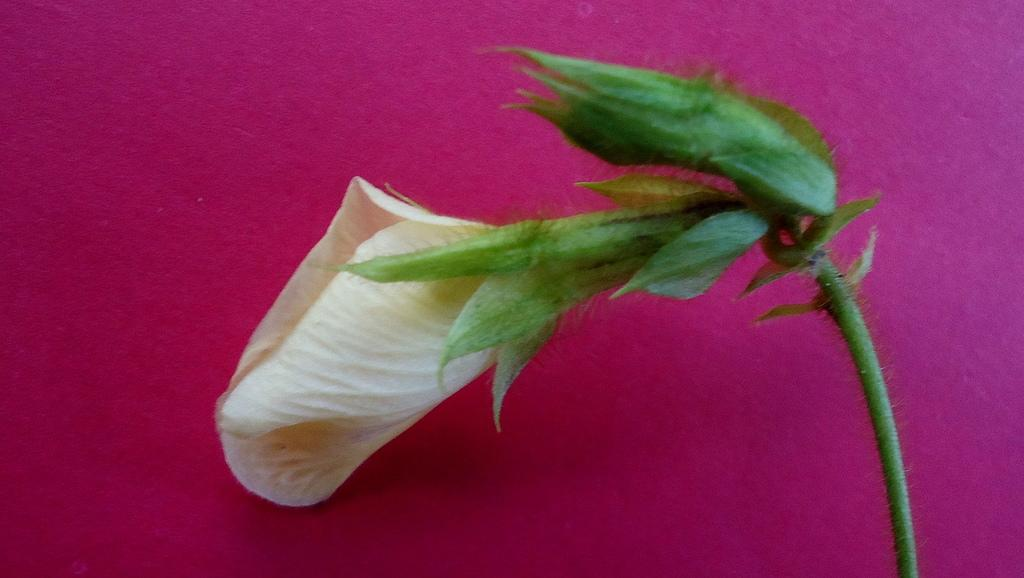What is the main subject of the image? There is a flower in the image. What type of laborer is depicted working on the flower in the image? There is no laborer present in the image, and the flower is not being worked on. What kind of breakfast is being served with the flower in the image? There is no breakfast present in the image, and the flower is not associated with any food. 